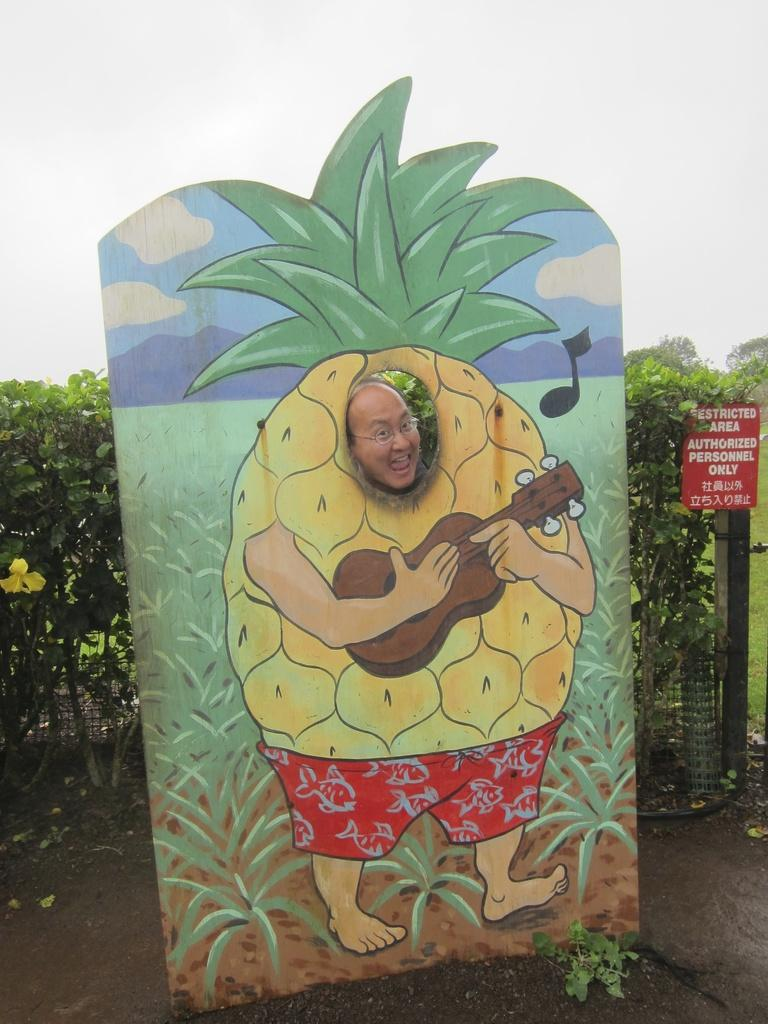What is the main object in the image? There is a board in the image. Can you describe the person in the image? The head of a person is visible in the image. What is located behind the board? There are trees behind the board. What type of material is visible in the image? There is a mesh visible in the image. What is located behind the mesh? There is another board behind the mesh. What part of the natural environment can be seen in the image? The sky is visible in the image. How does the man's eye journey through the image? There is no man or eye present in the image. 